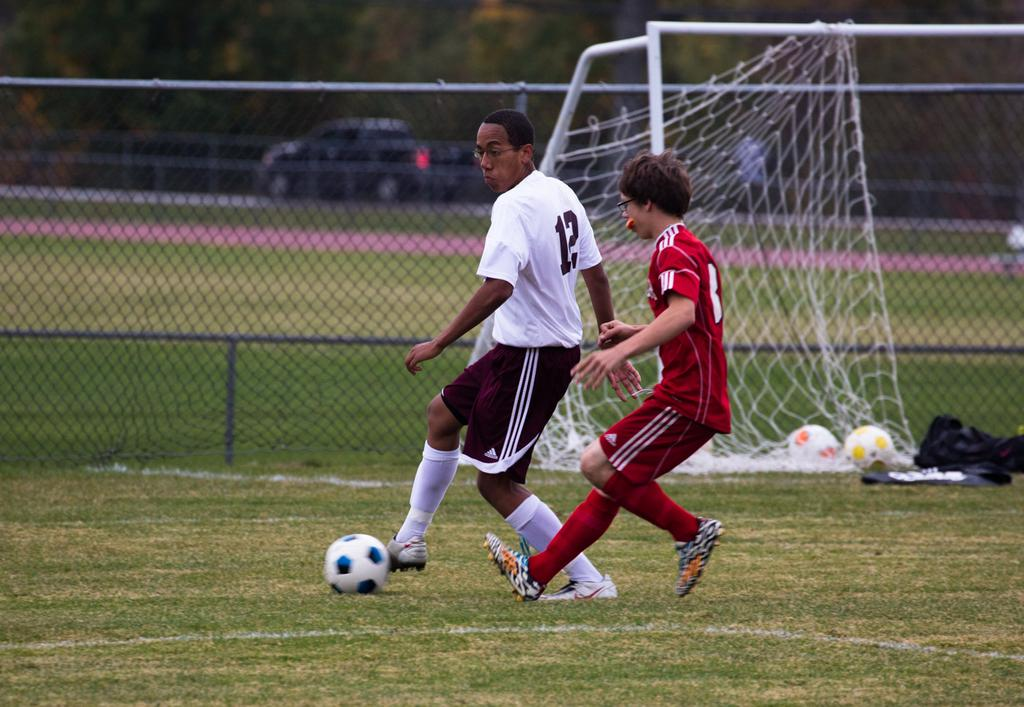<image>
Relay a brief, clear account of the picture shown. A player numbered 12 is attempting to steal the soccer ball from a man in a red jersey. 